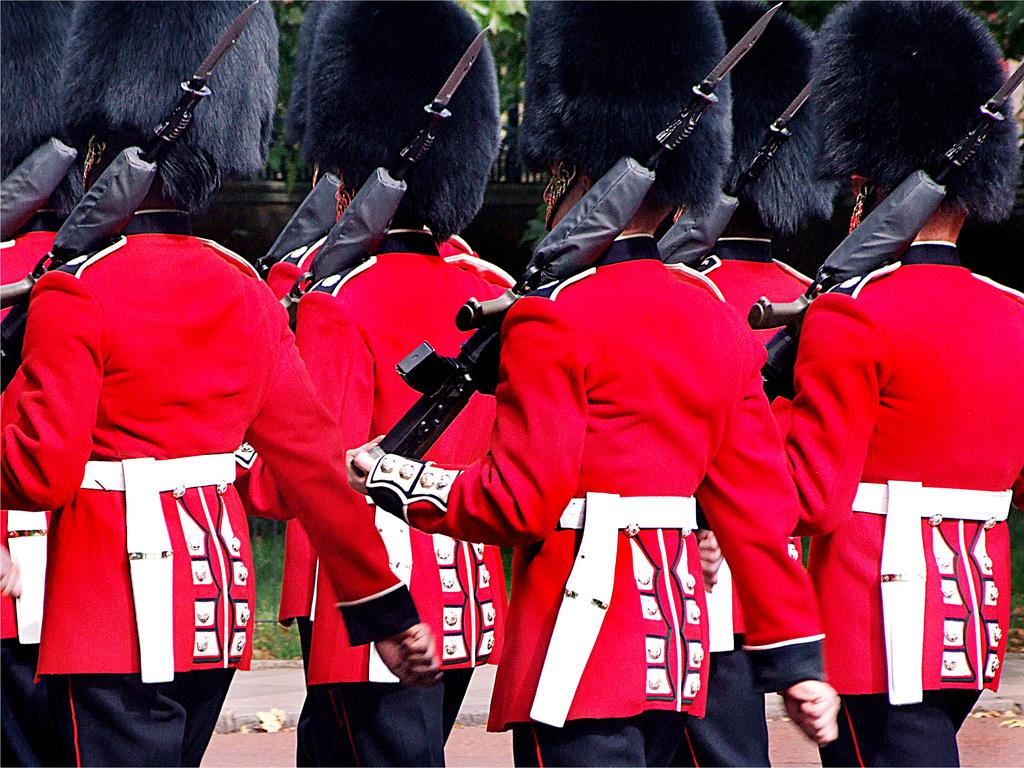How many people are in the image? There is a group of people in the image. What are the people holding in the image? The people are holding guns. What can be seen in the background of the image? There is a wall and trees visible in the background of the image. Can you see a basketball being played by the people in the image? There is no basketball present in the image. What type of neck accessory is worn by the people in the image? The people in the image are not wearing any neck accessories; they are holding guns. 